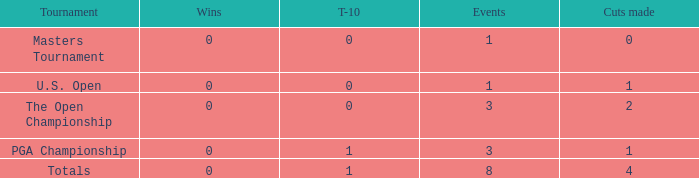For majors with 8 events played and more than 1 made cut, what is the most top-10s recorded? 1.0. 